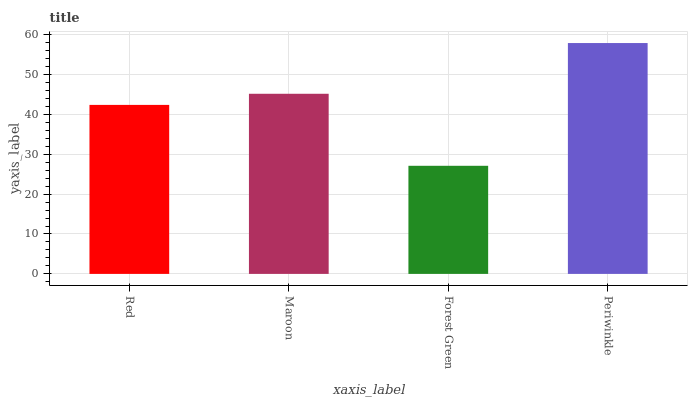Is Forest Green the minimum?
Answer yes or no. Yes. Is Periwinkle the maximum?
Answer yes or no. Yes. Is Maroon the minimum?
Answer yes or no. No. Is Maroon the maximum?
Answer yes or no. No. Is Maroon greater than Red?
Answer yes or no. Yes. Is Red less than Maroon?
Answer yes or no. Yes. Is Red greater than Maroon?
Answer yes or no. No. Is Maroon less than Red?
Answer yes or no. No. Is Maroon the high median?
Answer yes or no. Yes. Is Red the low median?
Answer yes or no. Yes. Is Red the high median?
Answer yes or no. No. Is Periwinkle the low median?
Answer yes or no. No. 